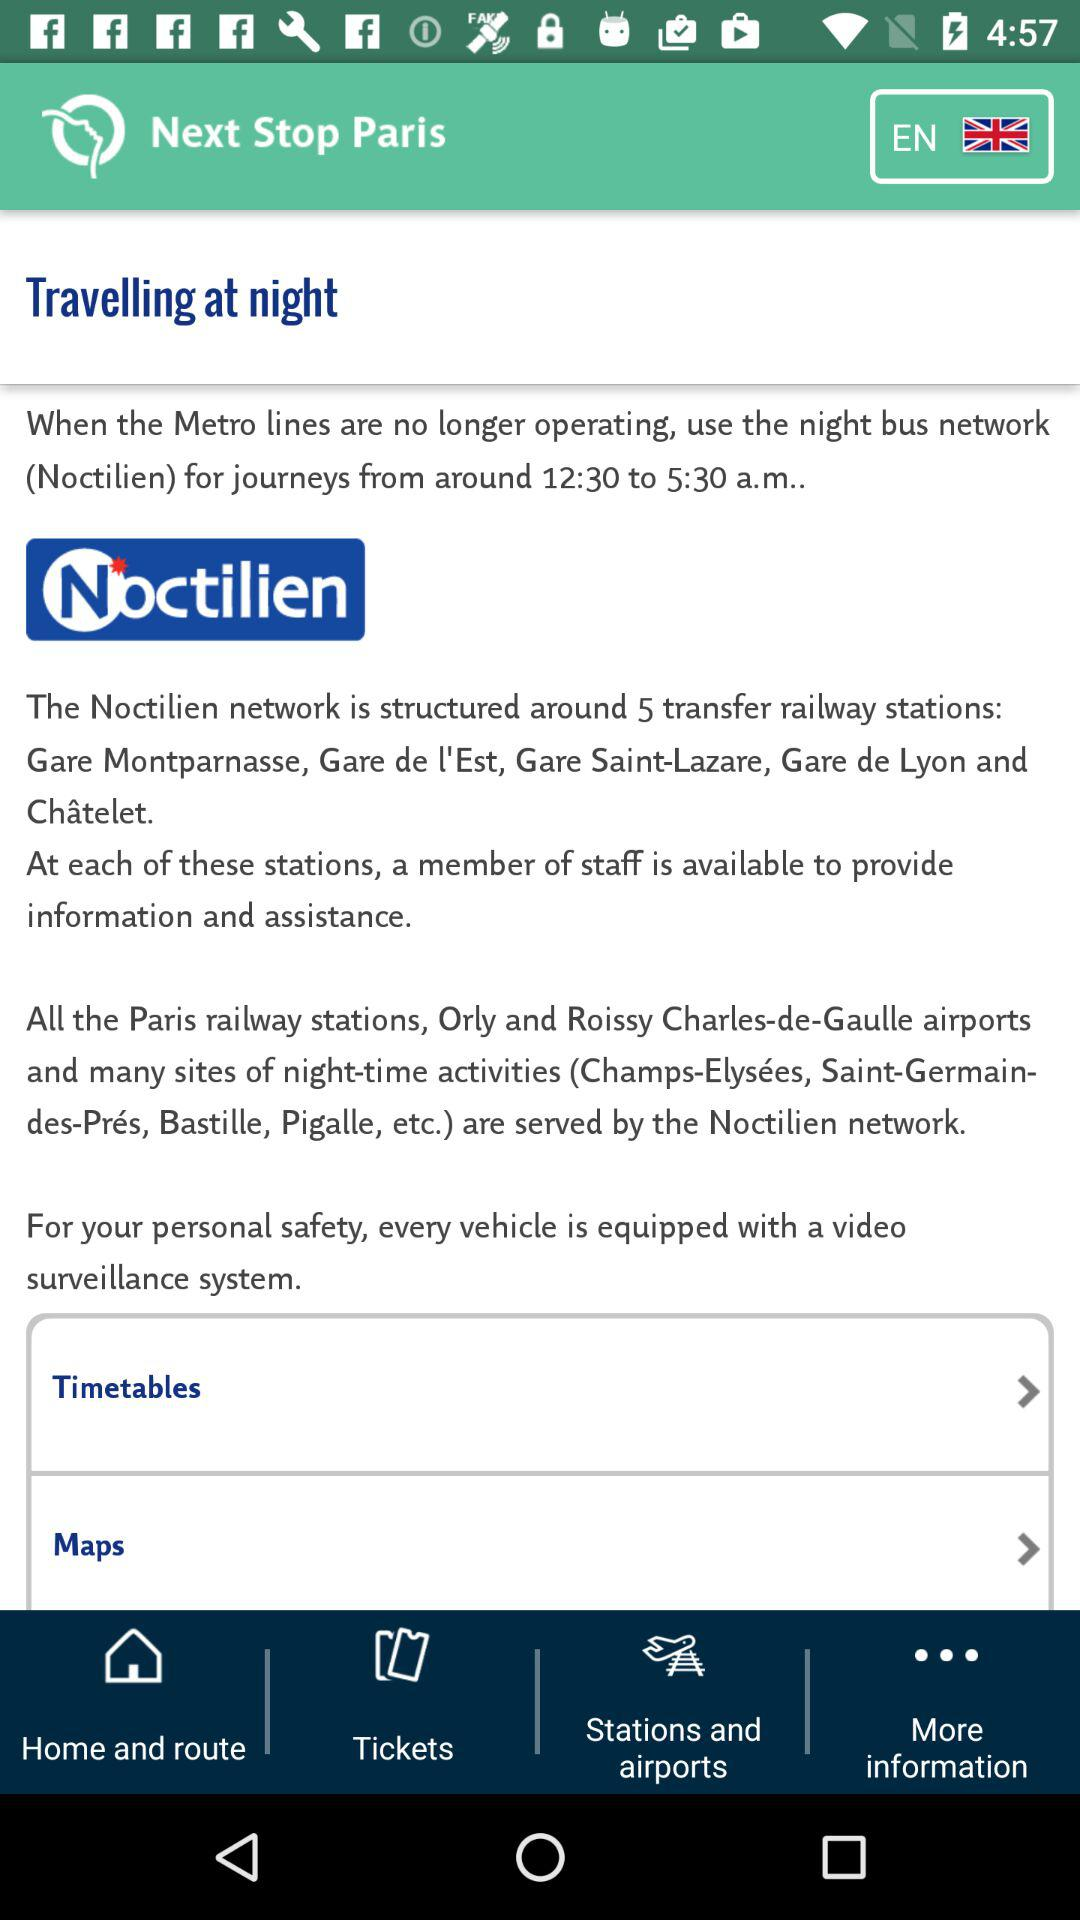What is the timing of the buses at night? The timing of the buses at night is from around 12:30 to 5:30 a.m. 